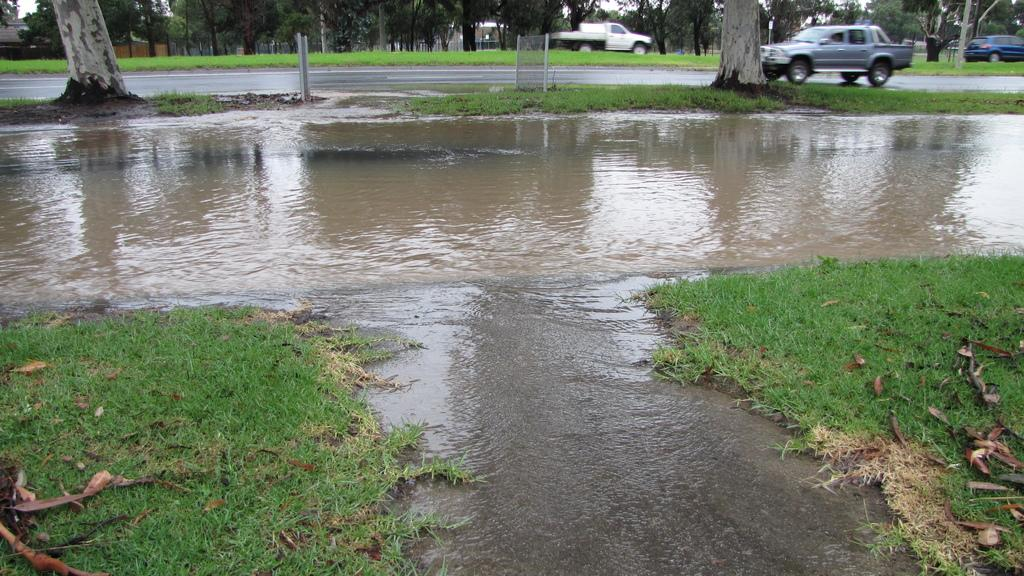What type of natural environment is visible at the bottom of the image? There is grass and water at the bottom of the image. What can be seen in the middle of the image? There are trees and vehicles in the middle of the image. What type of comfort can be seen in the image? There is no specific comfort depicted in the image; it features grass, water, trees, and vehicles. Is there a skateboard visible in the image? There is no skateboard present in the image. 